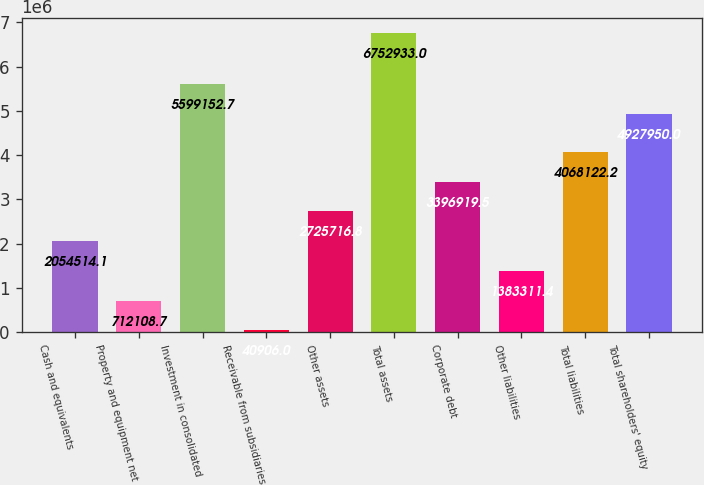Convert chart to OTSL. <chart><loc_0><loc_0><loc_500><loc_500><bar_chart><fcel>Cash and equivalents<fcel>Property and equipment net<fcel>Investment in consolidated<fcel>Receivable from subsidiaries<fcel>Other assets<fcel>Total assets<fcel>Corporate debt<fcel>Other liabilities<fcel>Total liabilities<fcel>Total shareholders' equity<nl><fcel>2.05451e+06<fcel>712109<fcel>5.59915e+06<fcel>40906<fcel>2.72572e+06<fcel>6.75293e+06<fcel>3.39692e+06<fcel>1.38331e+06<fcel>4.06812e+06<fcel>4.92795e+06<nl></chart> 